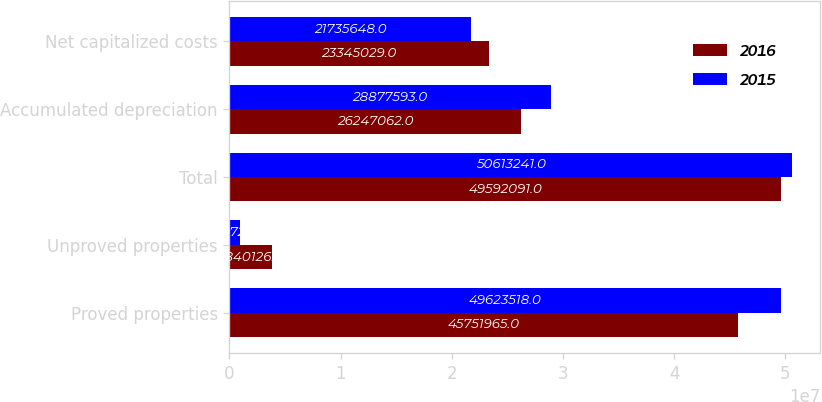Convert chart. <chart><loc_0><loc_0><loc_500><loc_500><stacked_bar_chart><ecel><fcel>Proved properties<fcel>Unproved properties<fcel>Total<fcel>Accumulated depreciation<fcel>Net capitalized costs<nl><fcel>2016<fcel>4.5752e+07<fcel>3.84013e+06<fcel>4.95921e+07<fcel>2.62471e+07<fcel>2.3345e+07<nl><fcel>2015<fcel>4.96235e+07<fcel>989723<fcel>5.06132e+07<fcel>2.88776e+07<fcel>2.17356e+07<nl></chart> 